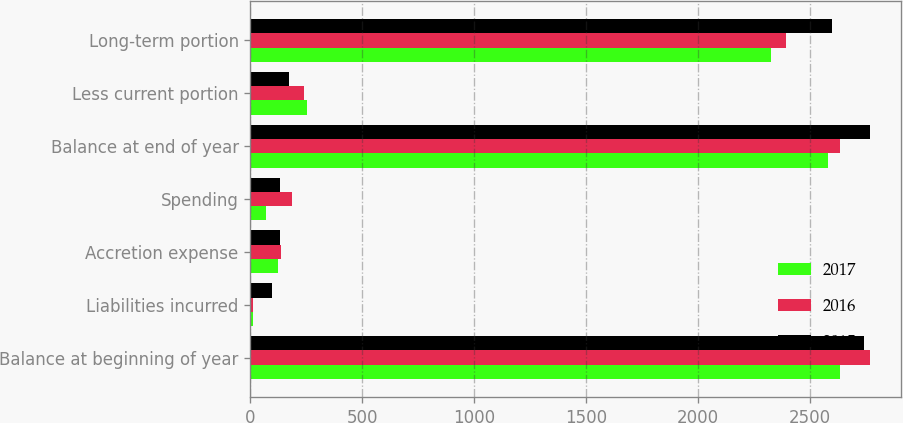Convert chart to OTSL. <chart><loc_0><loc_0><loc_500><loc_500><stacked_bar_chart><ecel><fcel>Balance at beginning of year<fcel>Liabilities incurred<fcel>Accretion expense<fcel>Spending<fcel>Balance at end of year<fcel>Less current portion<fcel>Long-term portion<nl><fcel>2017<fcel>2635<fcel>14<fcel>124<fcel>71<fcel>2580<fcel>254<fcel>2326<nl><fcel>2016<fcel>2771<fcel>12<fcel>137<fcel>188<fcel>2635<fcel>240<fcel>2395<nl><fcel>2015<fcel>2744<fcel>97<fcel>131<fcel>132<fcel>2771<fcel>172<fcel>2599<nl></chart> 